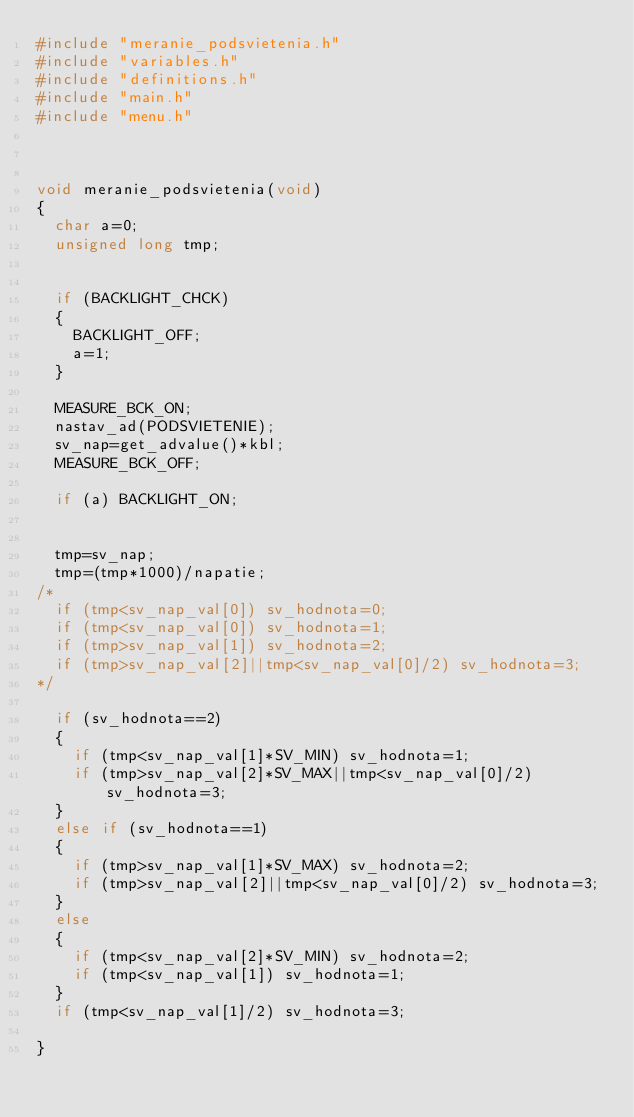Convert code to text. <code><loc_0><loc_0><loc_500><loc_500><_C_>#include "meranie_podsvietenia.h"
#include "variables.h"
#include "definitions.h"
#include "main.h"
#include "menu.h"



void meranie_podsvietenia(void)
{
	char a=0;
	unsigned long	tmp;


	if (BACKLIGHT_CHCK)
	{
		BACKLIGHT_OFF;
		a=1;
	}

	MEASURE_BCK_ON;
	nastav_ad(PODSVIETENIE);
	sv_nap=get_advalue()*kbl;
	MEASURE_BCK_OFF;

	if (a) BACKLIGHT_ON;


	tmp=sv_nap;
	tmp=(tmp*1000)/napatie;
/*	
	if (tmp<sv_nap_val[0]) sv_hodnota=0;
	if (tmp<sv_nap_val[0]) sv_hodnota=1;
	if (tmp>sv_nap_val[1]) sv_hodnota=2;
	if (tmp>sv_nap_val[2]||tmp<sv_nap_val[0]/2) sv_hodnota=3;
*/
	
	if (sv_hodnota==2)
	{
		if (tmp<sv_nap_val[1]*SV_MIN) sv_hodnota=1;
		if (tmp>sv_nap_val[2]*SV_MAX||tmp<sv_nap_val[0]/2) sv_hodnota=3;
	}
	else if (sv_hodnota==1)
	{
		if (tmp>sv_nap_val[1]*SV_MAX) sv_hodnota=2;
		if (tmp>sv_nap_val[2]||tmp<sv_nap_val[0]/2) sv_hodnota=3;
	}
	else
	{
		if (tmp<sv_nap_val[2]*SV_MIN) sv_hodnota=2;
		if (tmp<sv_nap_val[1]) sv_hodnota=1;
	}
	if (tmp<sv_nap_val[1]/2) sv_hodnota=3;

}
</code> 